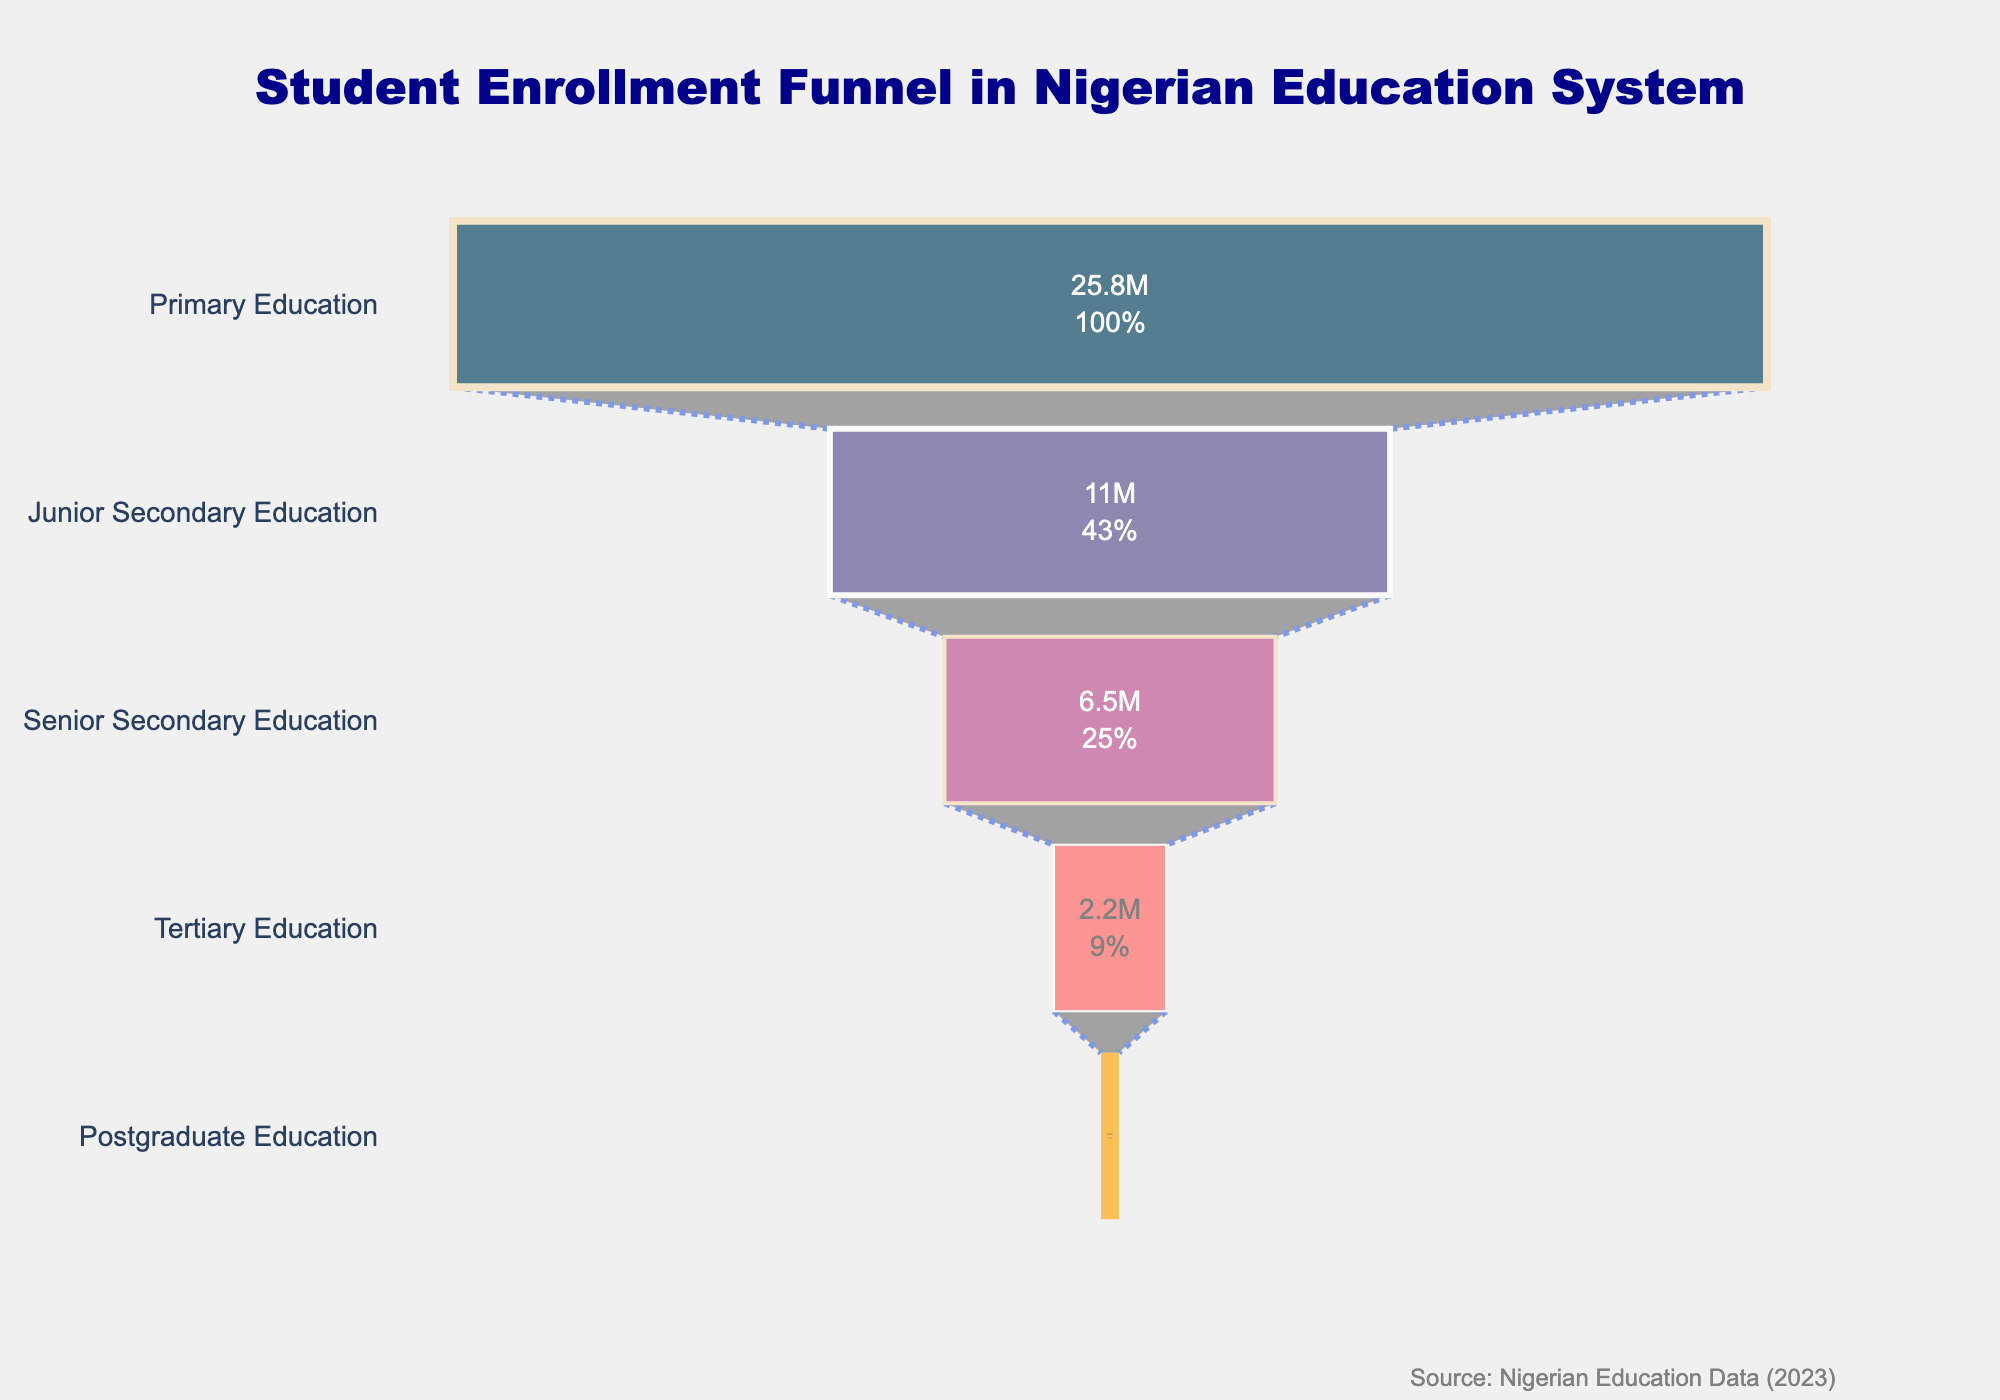What is the total enrollment in Primary Education? The enrollment for Primary Education is provided directly in the funnel chart. Look under the 'Primary Education' label.
Answer: 25,800,000 How many students are enrolled at the tertiary level of education in Nigeria? Find the 'Tertiary Education' level in the funnel chart and read the enrollment value directly.
Answer: 2,200,000 What is the percentage decrease in student enrollment from Primary to Junior Secondary Education? The enrollment drops from 25,800,000 in Primary to 11,000,000 in Junior Secondary. Calculate the percentage decrease using the formula: ((25,800,000 - 11,000,000) / 25,800,000) * 100.
Answer: 57.36% How does the enrollment in Senior Secondary Education compare to that in Tertiary Education? Find the enrollment numbers for both levels: 6,500,000 for Senior Secondary and 2,200,000 for Tertiary. Compare them directly to see that Senior Secondary is higher.
Answer: Senior Secondary is higher What percentage of students continue their education from Senior Secondary to Tertiary levels? Find the enrollment at Senior Secondary (6,500,000) and Tertiary (2,200,000). Use the formula (2,200,000 / 6,500,000) * 100 to calculate the percentage.
Answer: 33.85% Which level has the highest student enrollment? Look at the chart and identify the level with the longest bar, which represents the highest enrollment.
Answer: Primary Education What percentage of the total educational enrollment is at the postgraduate level? The total enrollment across all levels is the sum of individual enrollments: 25,800,000 + 11,000,000 + 6,500,000 + 2,200,000 + 350,000 = 45,850,000. Calculate the percentage as (350,000 / 45,850,000) * 100.
Answer: 0.76% What is the enrollment trend as students progress through higher levels of education? Observe the lengths of the bars from top to bottom. Each subsequent educational level has fewer students, indicating a decreasing trend in student enrollment.
Answer: Decreasing If there are 10 educational levels, how would the midpoint in enrollment compare to the currently listed levels? Consider the median level in enrollment among the listed five levels, which is the third one (Senior Secondary Education with 6,500,000). Compare this hypothetically to the 10-level system if the trend continues similarly.
Answer: It would likely fall below Senior Secondary Education What are the colors used in the funnel chart for Primary and Tertiary levels of education? Identify the colors used in the chart for both Primary and Tertiary levels (the first and fourth segments).
Answer: Dark Blue for Primary, Light Orange for Tertiary 